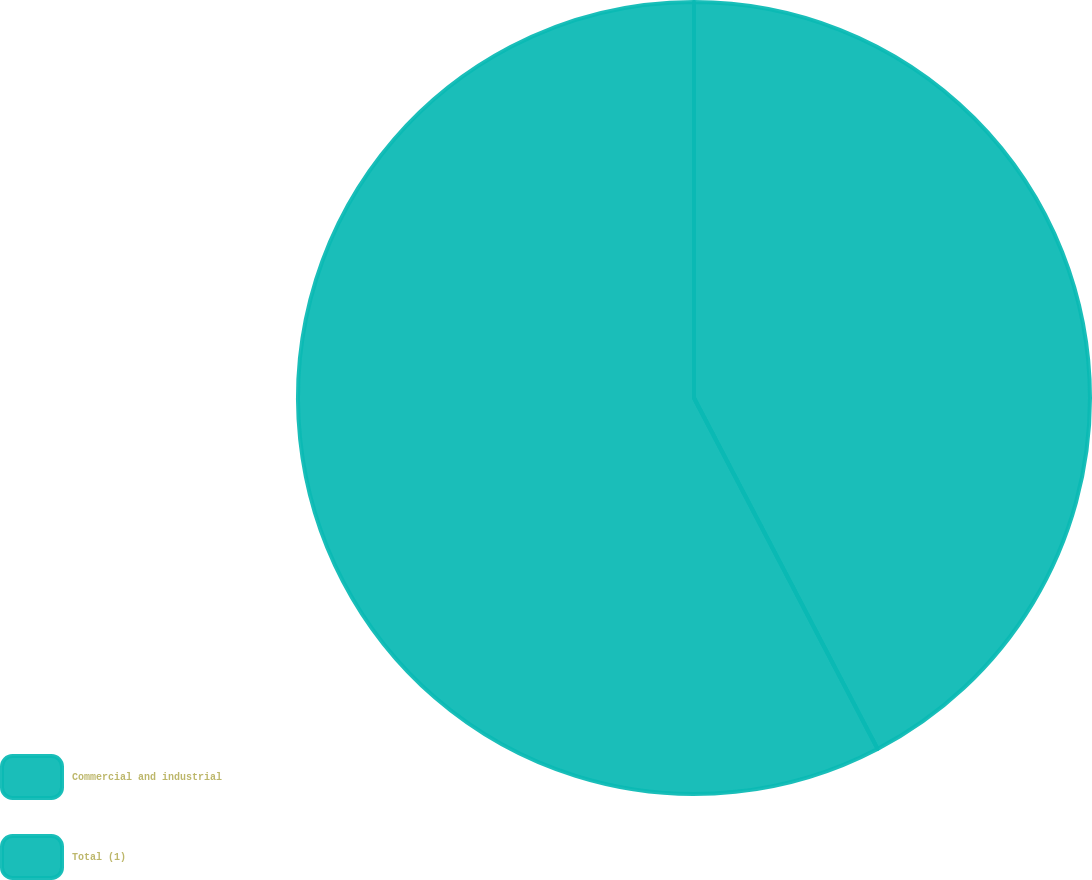Convert chart to OTSL. <chart><loc_0><loc_0><loc_500><loc_500><pie_chart><fcel>Commercial and industrial<fcel>Total (1)<nl><fcel>42.33%<fcel>57.67%<nl></chart> 